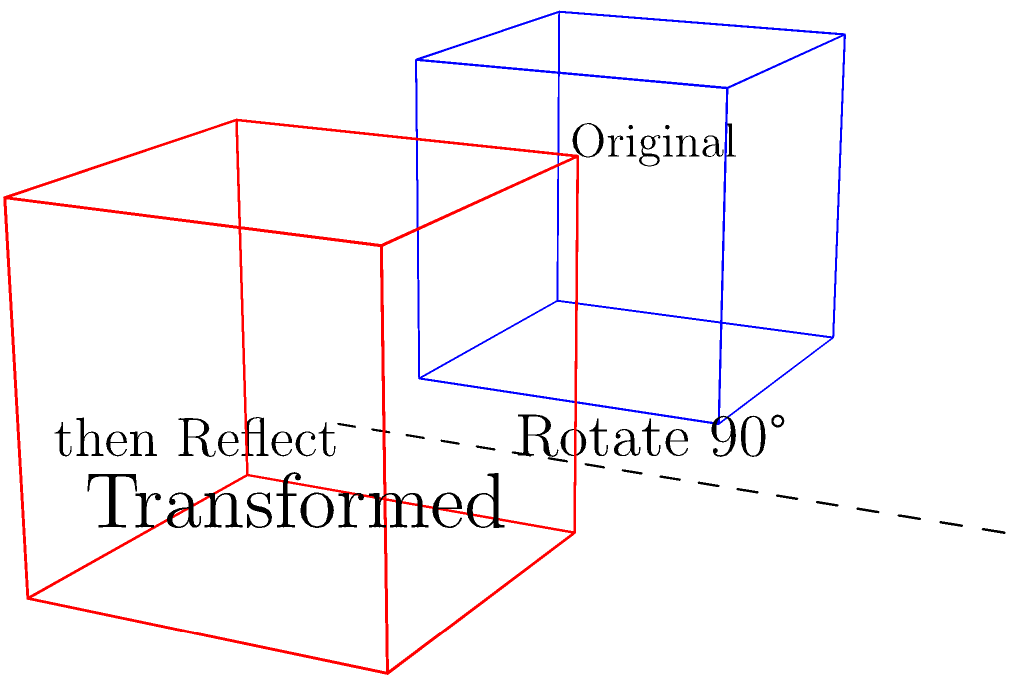As you reflect on your geometry coursework, consider the following 3D transformation problem:

A unit cube is first rotated 90° clockwise around the y-axis, then reflected across the yz-plane. What is the resulting transformation matrix that represents this sequence of operations? Let's approach this step-by-step:

1) First, let's recall the rotation matrix for a 90° clockwise rotation around the y-axis:

   $$R_y(90°) = \begin{pmatrix}
   0 & 0 & 1 \\
   0 & 1 & 0 \\
   -1 & 0 & 0
   \end{pmatrix}$$

2) Next, the reflection matrix across the yz-plane is:

   $$M_{yz} = \begin{pmatrix}
   -1 & 0 & 0 \\
   0 & 1 & 0 \\
   0 & 0 & 1
   \end{pmatrix}$$

3) To get the final transformation matrix, we need to multiply these matrices in the order of operations. Remember, matrix multiplication is not commutative, so the order matters. We reflect after rotating, so we multiply the reflection matrix by the rotation matrix:

   $$T = M_{yz} \cdot R_y(90°)$$

4) Let's perform this multiplication:

   $$\begin{pmatrix}
   -1 & 0 & 0 \\
   0 & 1 & 0 \\
   0 & 0 & 1
   \end{pmatrix} \cdot 
   \begin{pmatrix}
   0 & 0 & 1 \\
   0 & 1 & 0 \\
   -1 & 0 & 0
   \end{pmatrix} = 
   \begin{pmatrix}
   0 & 0 & -1 \\
   0 & 1 & 0 \\
   -1 & 0 & 0
   \end{pmatrix}$$

5) This resulting matrix represents the complete transformation.
Answer: $$\begin{pmatrix}
0 & 0 & -1 \\
0 & 1 & 0 \\
-1 & 0 & 0
\end{pmatrix}$$ 